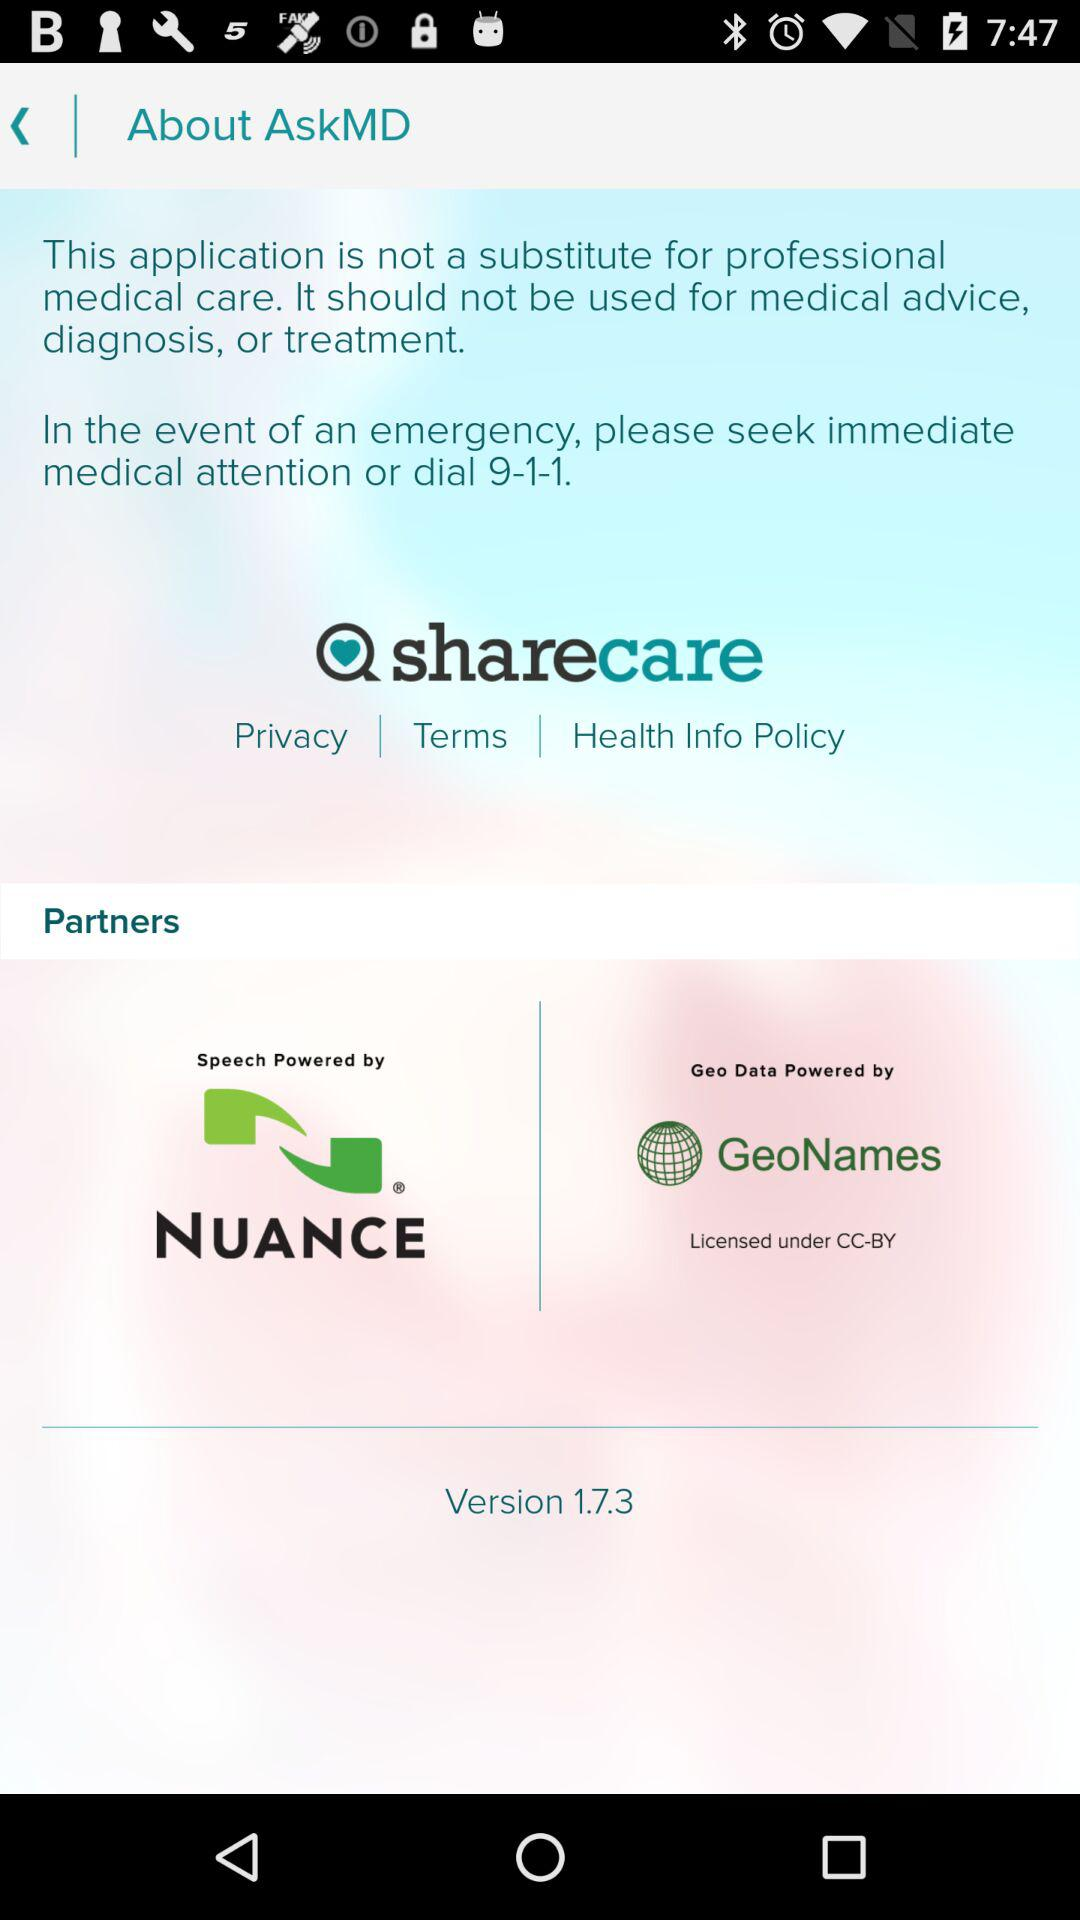When did version 1.7.3 launch?
When the provided information is insufficient, respond with <no answer>. <no answer> 